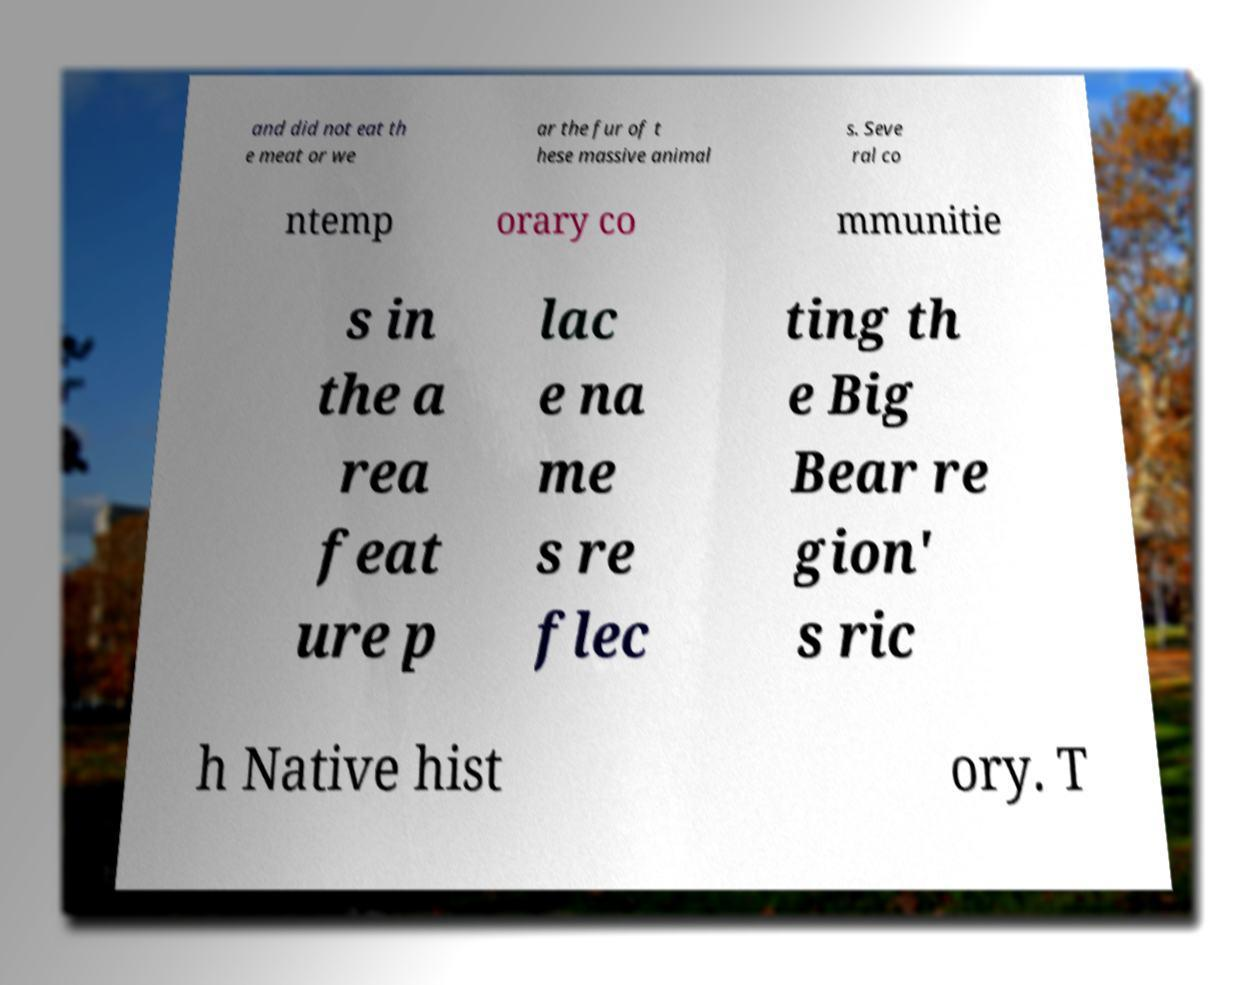What messages or text are displayed in this image? I need them in a readable, typed format. and did not eat th e meat or we ar the fur of t hese massive animal s. Seve ral co ntemp orary co mmunitie s in the a rea feat ure p lac e na me s re flec ting th e Big Bear re gion' s ric h Native hist ory. T 